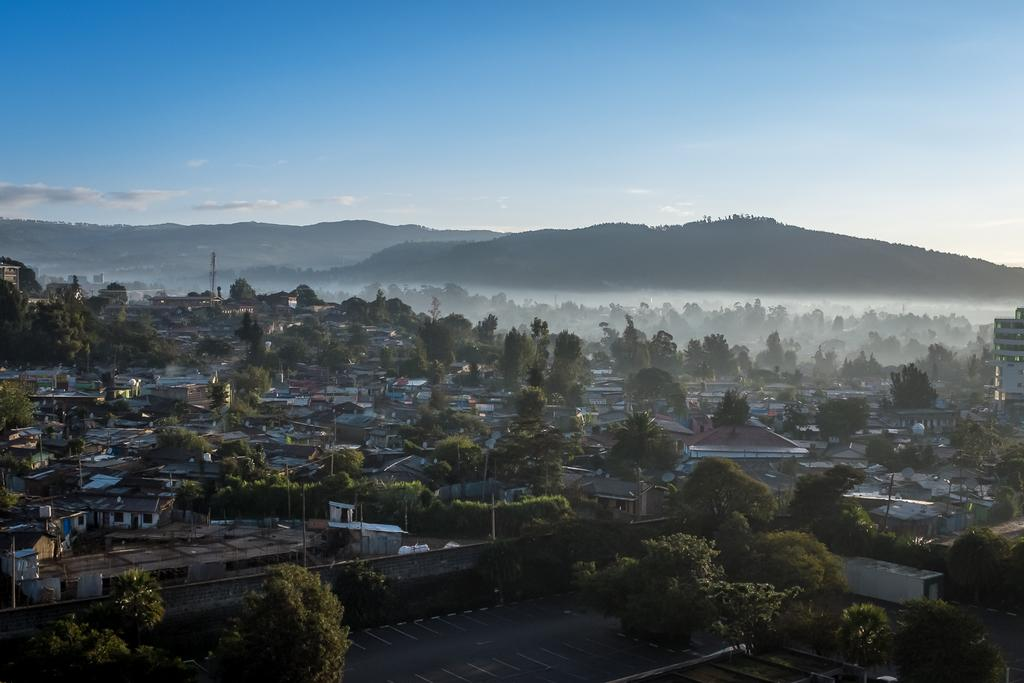What type of natural elements can be seen in the image? There are many trees in the image. What type of man-made structures are present in the image? There are buildings in the image. What type of vertical structures can be seen in the image? There are many poles in the image. What type of geographical features are present in the image? There are hills in the image. What is the condition of the sky in the image? The sky is clear in the image. What type of engine can be seen in the image? There is no engine present in the image. What type of advice might the grandmother give in the image? There is no grandmother present in the image. 